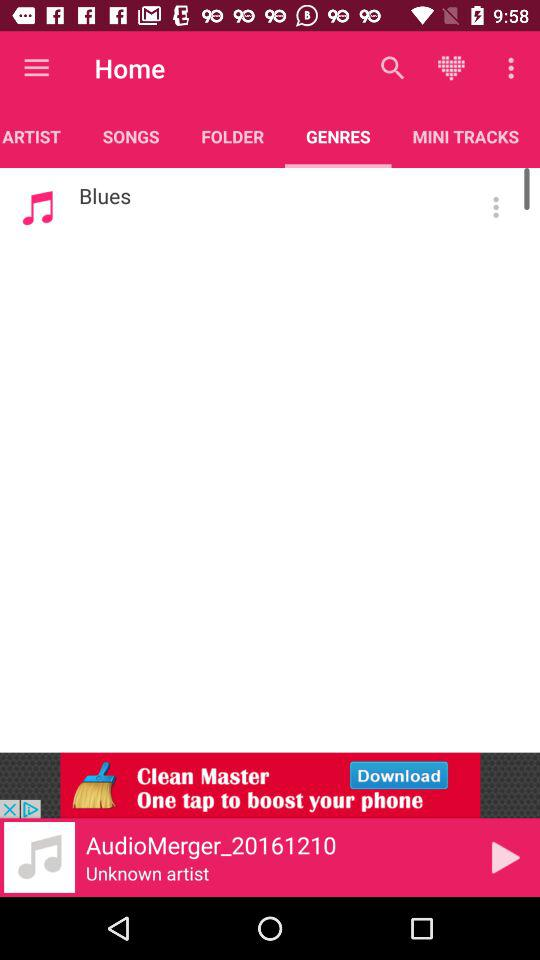Which song is currently playing? The song is AudioMerger_20161210. 